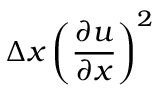Convert formula to latex. <formula><loc_0><loc_0><loc_500><loc_500>\Delta x \left ( \frac { \partial u } { \partial x } \right ) ^ { 2 }</formula> 